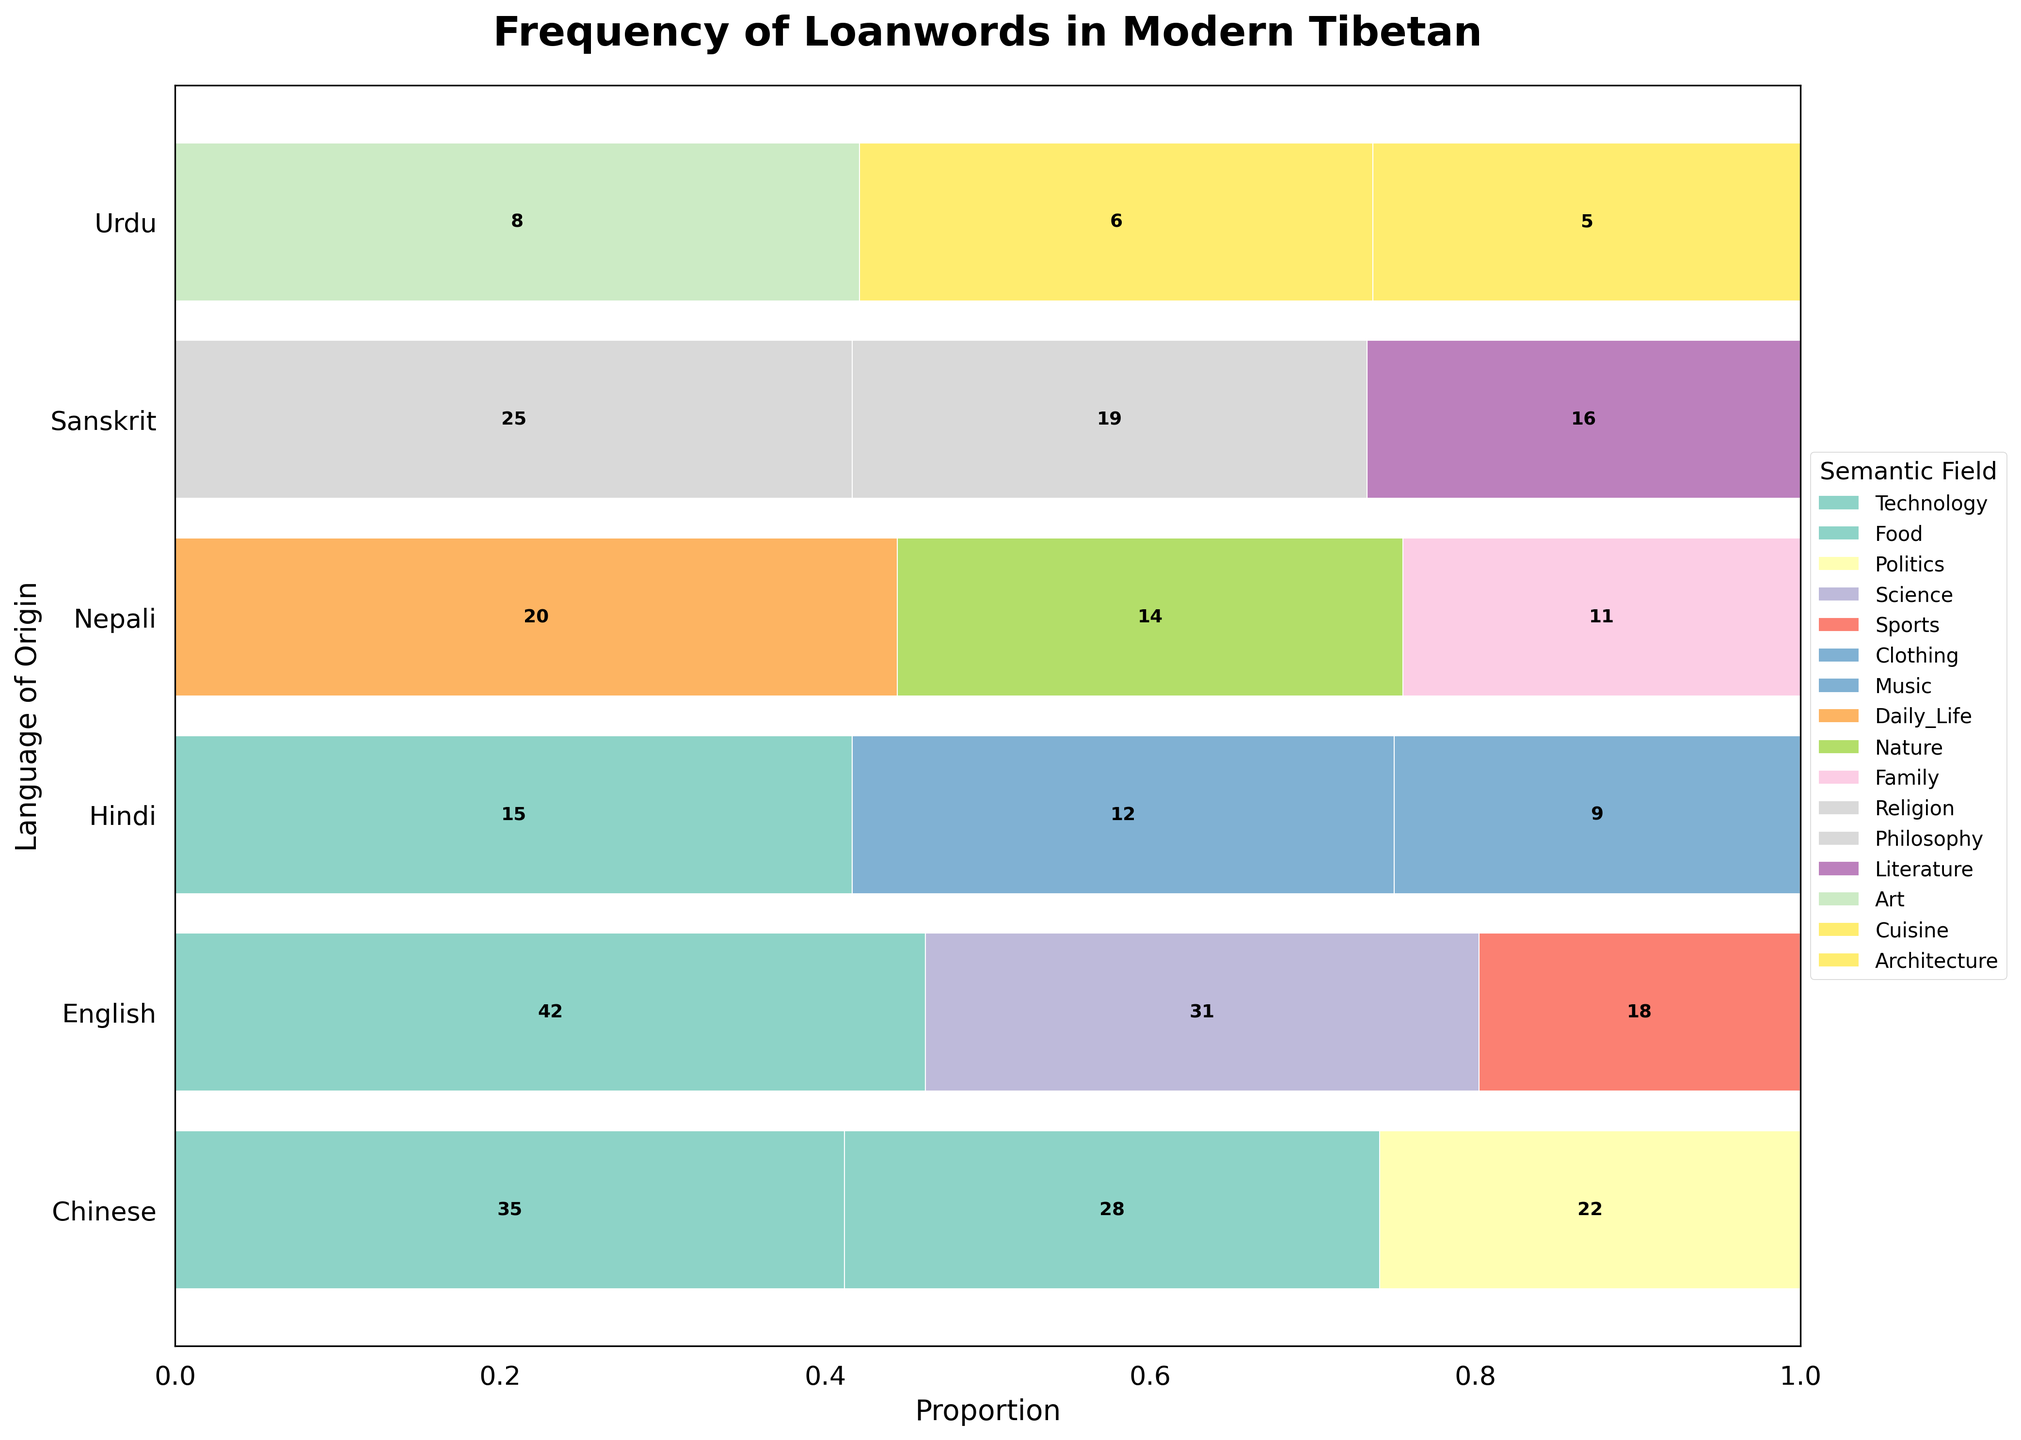what is the title of the plot? The title is clearly listed at the top of the plot. It reads: "Frequency of Loanwords in Modern Tibetan".
Answer: Frequency of Loanwords in Modern Tibetan which language has the highest frequency of loanwords in the technology semantic field? By looking at the plot, you can see that the bar segment for the Technology field in English is the largest compared to other languages.
Answer: English how many semantic fields contain loanwords originating from Nepali? Look at the bars for Nepali and count how many different colors (semantic fields) are represented. These are Daily Life, Nature, and Family.
Answer: Three which semantic field has the smallest frequency of loanwords originating from Urdu? Examine the bars associated with Urdu; the segment with the smallest proportion is Architecture.
Answer: Architecture compare the frequency of loanwords from Sanskrit in the fields of Religion and Literature. Which field has a higher frequency? By comparing the segments for Sanskrit related to Religion and Literature, you can see that the Religion segment is larger than the Literature segment.
Answer: Religion what is the total frequency of loanwords originating from Hindi across all semantic fields? Sum the frequencies for all semantic fields in Hindi, which are Food (15) + Clothing (12) + Music (9).
Answer: 36 which semantic field has the highest total frequency of loanwords across all languages? By summing the segments for each semantic field across different languages, you can find that the Technology field has the highest total frequency.
Answer: Technology compare the proportions of loanwords in the Food field from Chinese and Hindi; which language has a higher proportion? Look at the proportional lengths of the Food segments for Chinese and Hindi; the segment for Chinese is longer than that for Hindi.
Answer: Chinese what is the proportion of loanwords in the Science field from English? Examine the length of the Science segment in the English bar relative to the total length of the English bar.
Answer: Approximately 29.5% in which semantic field do Hindi and Nepali have nearly equal frequencies of loanwords? Look at the bars for Hindi and Nepali across all fields; the Food and Daily Life segments are not close, but Nature has similar lengths.
Answer: None 